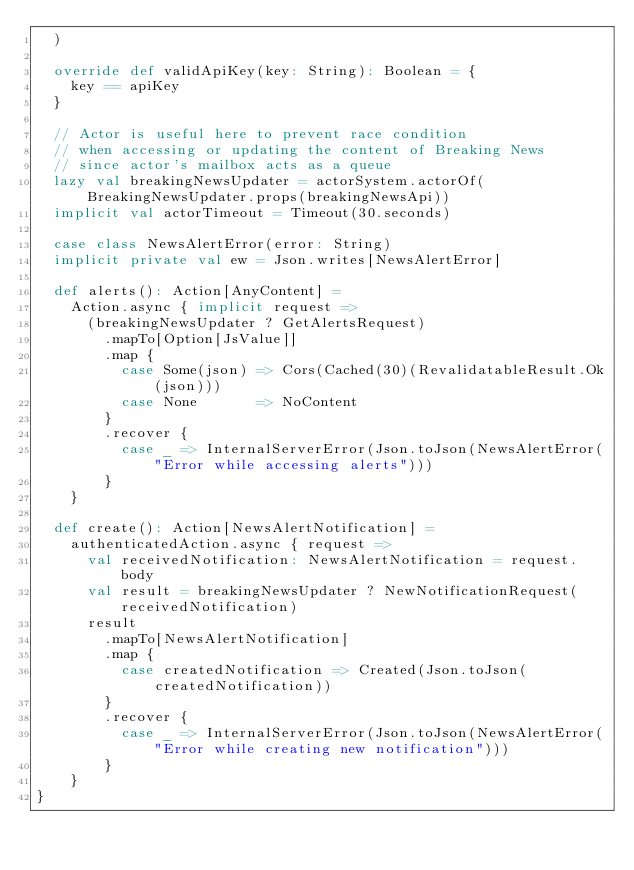<code> <loc_0><loc_0><loc_500><loc_500><_Scala_>  )

  override def validApiKey(key: String): Boolean = {
    key == apiKey
  }

  // Actor is useful here to prevent race condition
  // when accessing or updating the content of Breaking News
  // since actor's mailbox acts as a queue
  lazy val breakingNewsUpdater = actorSystem.actorOf(BreakingNewsUpdater.props(breakingNewsApi))
  implicit val actorTimeout = Timeout(30.seconds)

  case class NewsAlertError(error: String)
  implicit private val ew = Json.writes[NewsAlertError]

  def alerts(): Action[AnyContent] =
    Action.async { implicit request =>
      (breakingNewsUpdater ? GetAlertsRequest)
        .mapTo[Option[JsValue]]
        .map {
          case Some(json) => Cors(Cached(30)(RevalidatableResult.Ok(json)))
          case None       => NoContent
        }
        .recover {
          case _ => InternalServerError(Json.toJson(NewsAlertError("Error while accessing alerts")))
        }
    }

  def create(): Action[NewsAlertNotification] =
    authenticatedAction.async { request =>
      val receivedNotification: NewsAlertNotification = request.body
      val result = breakingNewsUpdater ? NewNotificationRequest(receivedNotification)
      result
        .mapTo[NewsAlertNotification]
        .map {
          case createdNotification => Created(Json.toJson(createdNotification))
        }
        .recover {
          case _ => InternalServerError(Json.toJson(NewsAlertError("Error while creating new notification")))
        }
    }
}
</code> 